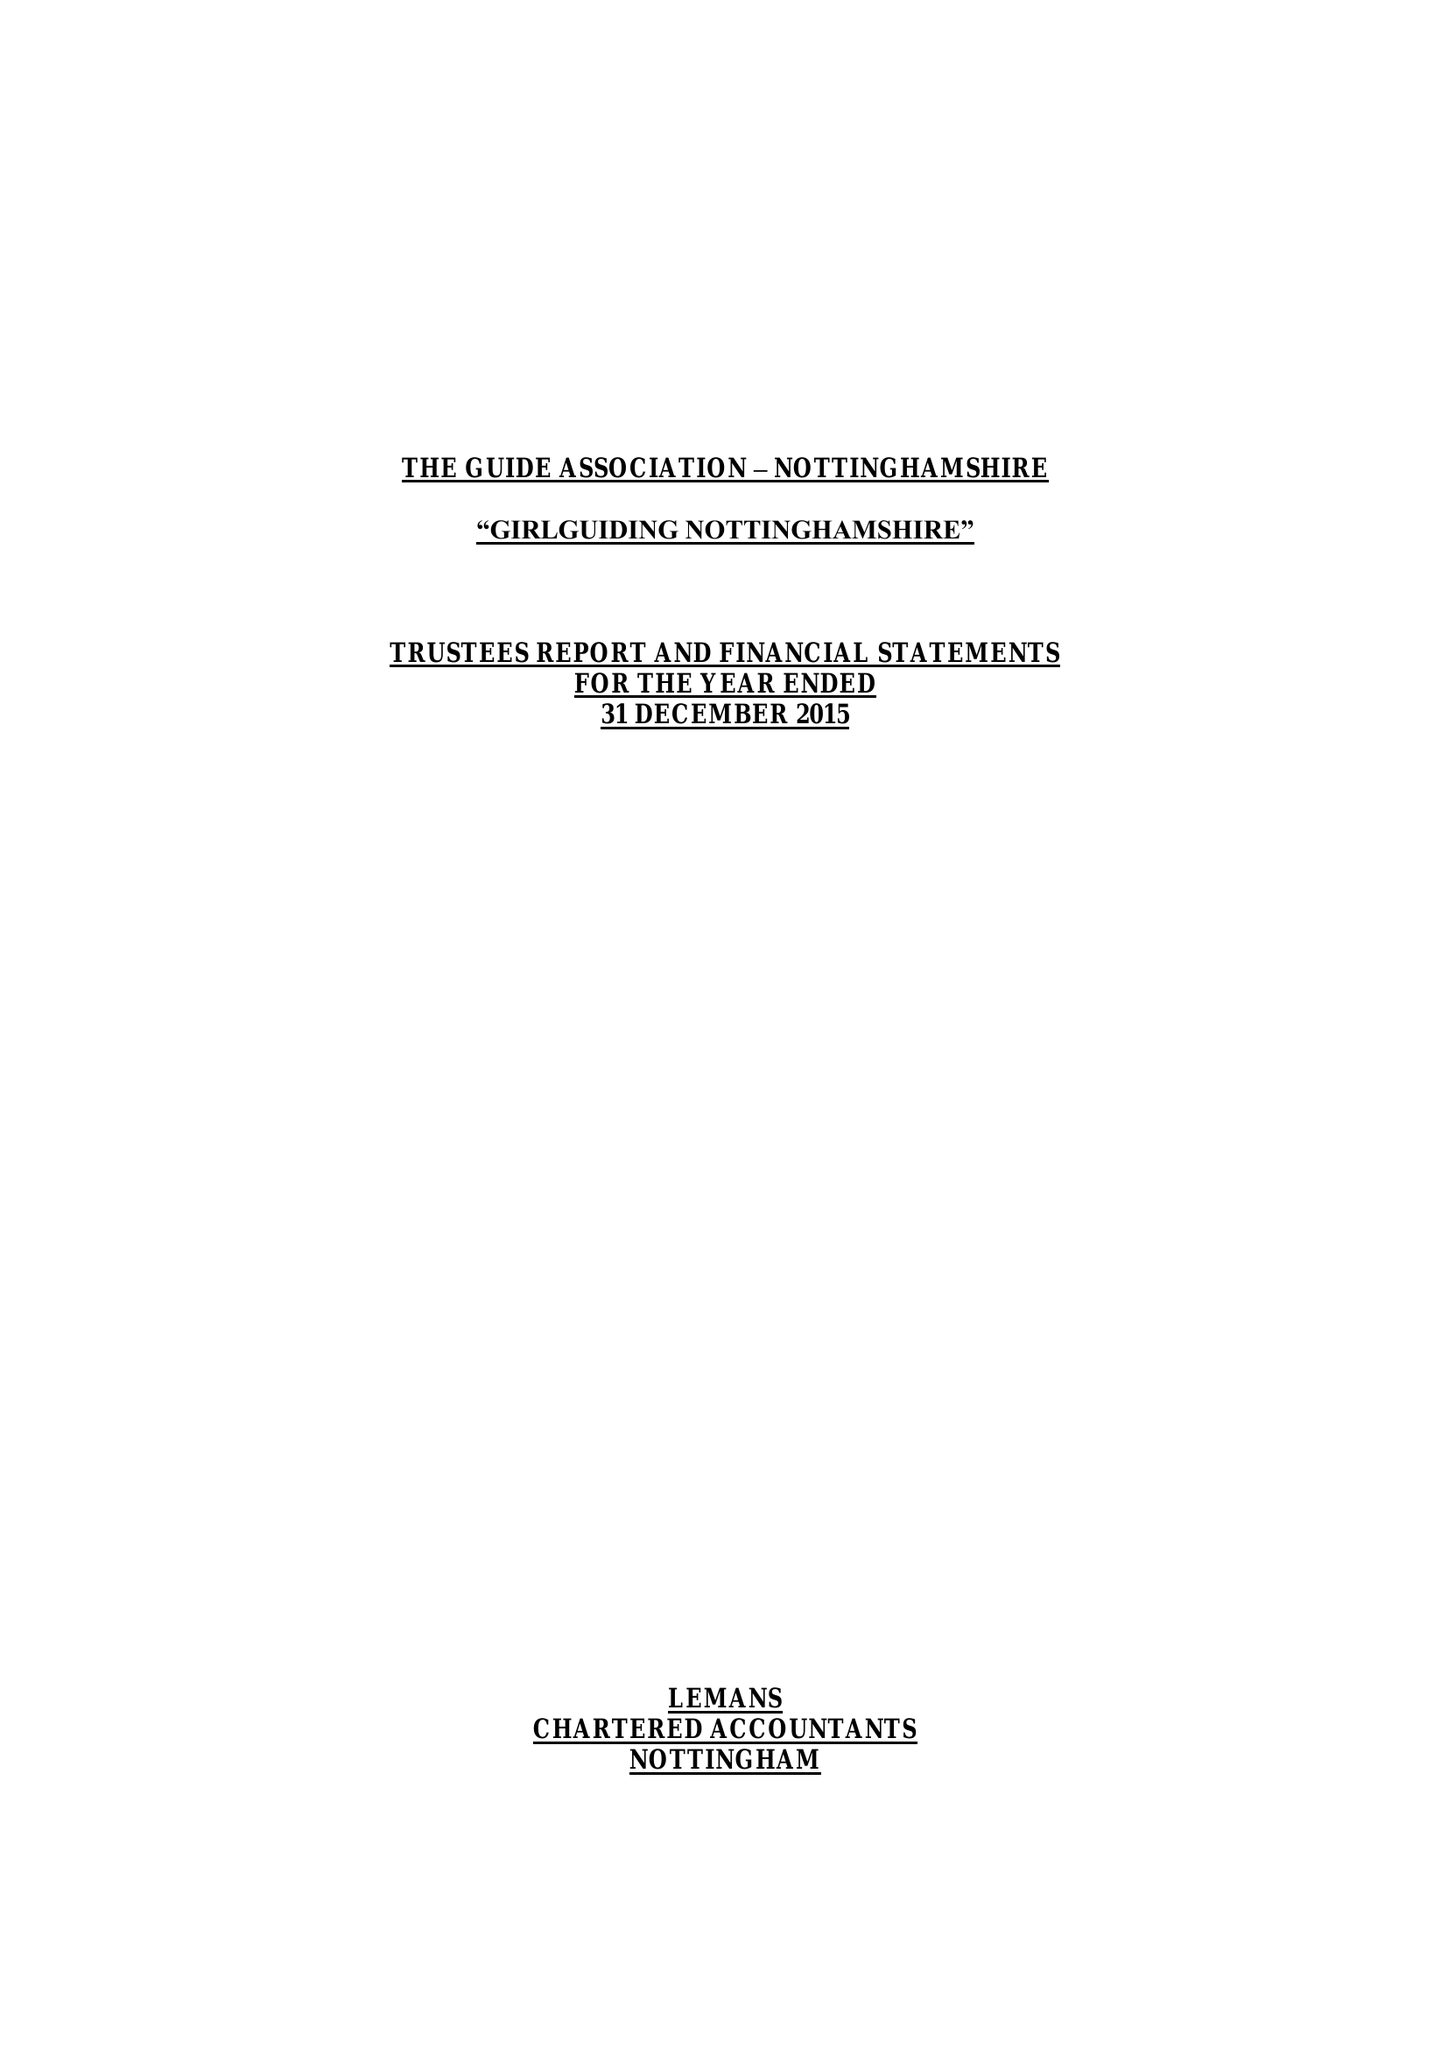What is the value for the charity_number?
Answer the question using a single word or phrase. 503168 